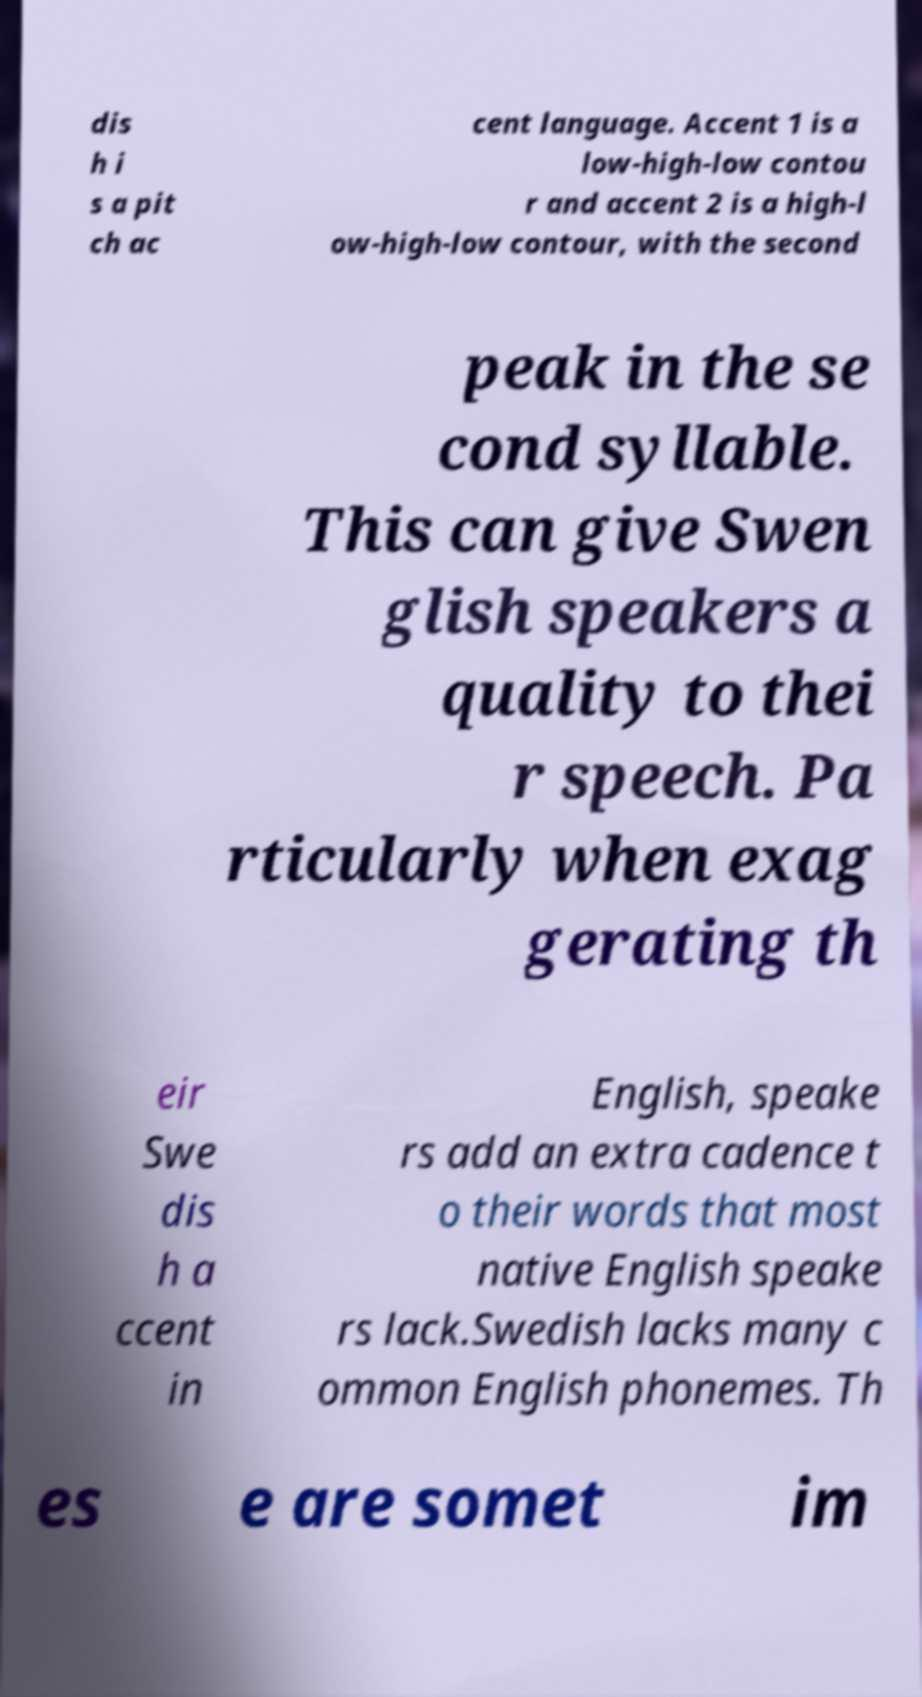I need the written content from this picture converted into text. Can you do that? dis h i s a pit ch ac cent language. Accent 1 is a low-high-low contou r and accent 2 is a high-l ow-high-low contour, with the second peak in the se cond syllable. This can give Swen glish speakers a quality to thei r speech. Pa rticularly when exag gerating th eir Swe dis h a ccent in English, speake rs add an extra cadence t o their words that most native English speake rs lack.Swedish lacks many c ommon English phonemes. Th es e are somet im 